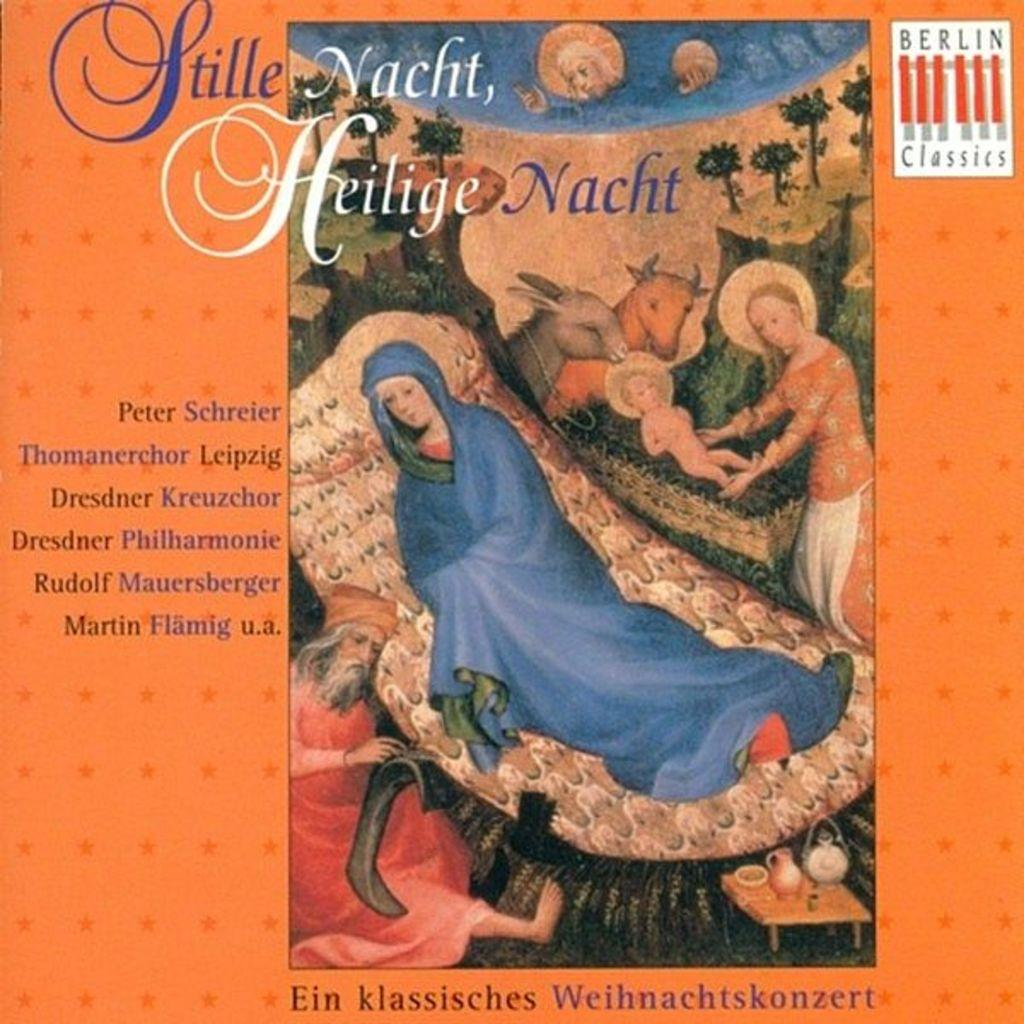<image>
Provide a brief description of the given image. A foreign poster for something called Stille Nacht, by Peter Schreier. 